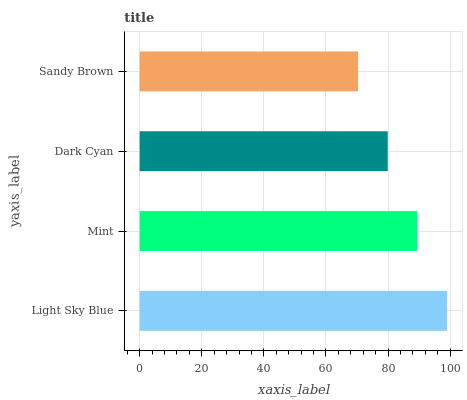Is Sandy Brown the minimum?
Answer yes or no. Yes. Is Light Sky Blue the maximum?
Answer yes or no. Yes. Is Mint the minimum?
Answer yes or no. No. Is Mint the maximum?
Answer yes or no. No. Is Light Sky Blue greater than Mint?
Answer yes or no. Yes. Is Mint less than Light Sky Blue?
Answer yes or no. Yes. Is Mint greater than Light Sky Blue?
Answer yes or no. No. Is Light Sky Blue less than Mint?
Answer yes or no. No. Is Mint the high median?
Answer yes or no. Yes. Is Dark Cyan the low median?
Answer yes or no. Yes. Is Light Sky Blue the high median?
Answer yes or no. No. Is Light Sky Blue the low median?
Answer yes or no. No. 